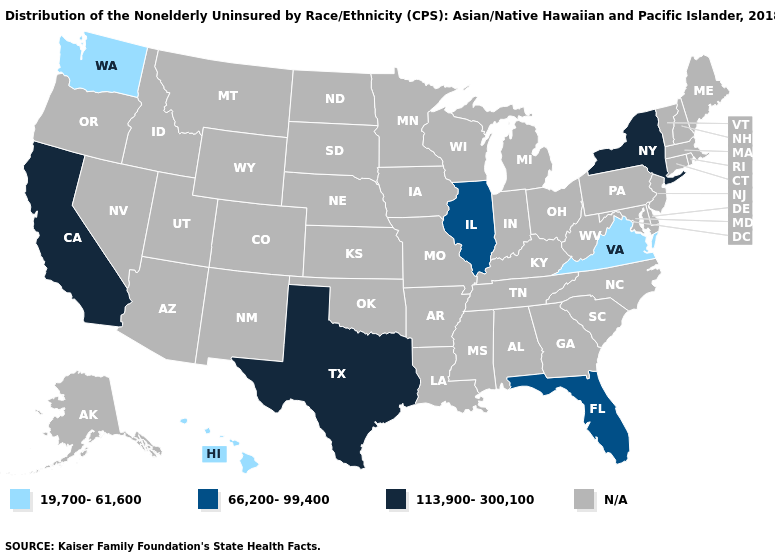Name the states that have a value in the range N/A?
Answer briefly. Alabama, Alaska, Arizona, Arkansas, Colorado, Connecticut, Delaware, Georgia, Idaho, Indiana, Iowa, Kansas, Kentucky, Louisiana, Maine, Maryland, Massachusetts, Michigan, Minnesota, Mississippi, Missouri, Montana, Nebraska, Nevada, New Hampshire, New Jersey, New Mexico, North Carolina, North Dakota, Ohio, Oklahoma, Oregon, Pennsylvania, Rhode Island, South Carolina, South Dakota, Tennessee, Utah, Vermont, West Virginia, Wisconsin, Wyoming. What is the value of Tennessee?
Quick response, please. N/A. Name the states that have a value in the range N/A?
Write a very short answer. Alabama, Alaska, Arizona, Arkansas, Colorado, Connecticut, Delaware, Georgia, Idaho, Indiana, Iowa, Kansas, Kentucky, Louisiana, Maine, Maryland, Massachusetts, Michigan, Minnesota, Mississippi, Missouri, Montana, Nebraska, Nevada, New Hampshire, New Jersey, New Mexico, North Carolina, North Dakota, Ohio, Oklahoma, Oregon, Pennsylvania, Rhode Island, South Carolina, South Dakota, Tennessee, Utah, Vermont, West Virginia, Wisconsin, Wyoming. Does the map have missing data?
Concise answer only. Yes. What is the value of Michigan?
Write a very short answer. N/A. Name the states that have a value in the range 113,900-300,100?
Short answer required. California, New York, Texas. What is the value of Vermont?
Short answer required. N/A. Which states have the lowest value in the South?
Concise answer only. Virginia. Name the states that have a value in the range 113,900-300,100?
Give a very brief answer. California, New York, Texas. What is the highest value in the MidWest ?
Concise answer only. 66,200-99,400. What is the highest value in the South ?
Answer briefly. 113,900-300,100. Does Hawaii have the lowest value in the USA?
Answer briefly. Yes. What is the value of Maryland?
Quick response, please. N/A. Does the first symbol in the legend represent the smallest category?
Answer briefly. Yes. 